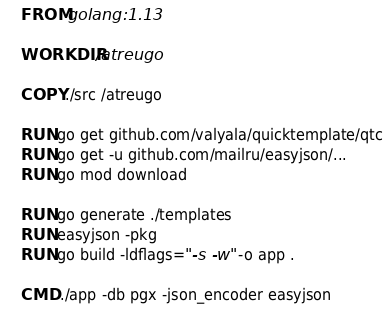<code> <loc_0><loc_0><loc_500><loc_500><_Dockerfile_>FROM golang:1.13

WORKDIR /atreugo

COPY ./src /atreugo

RUN go get github.com/valyala/quicktemplate/qtc
RUN go get -u github.com/mailru/easyjson/...
RUN go mod download

RUN go generate ./templates
RUN easyjson -pkg
RUN go build -ldflags="-s -w" -o app .

CMD ./app -db pgx -json_encoder easyjson
</code> 